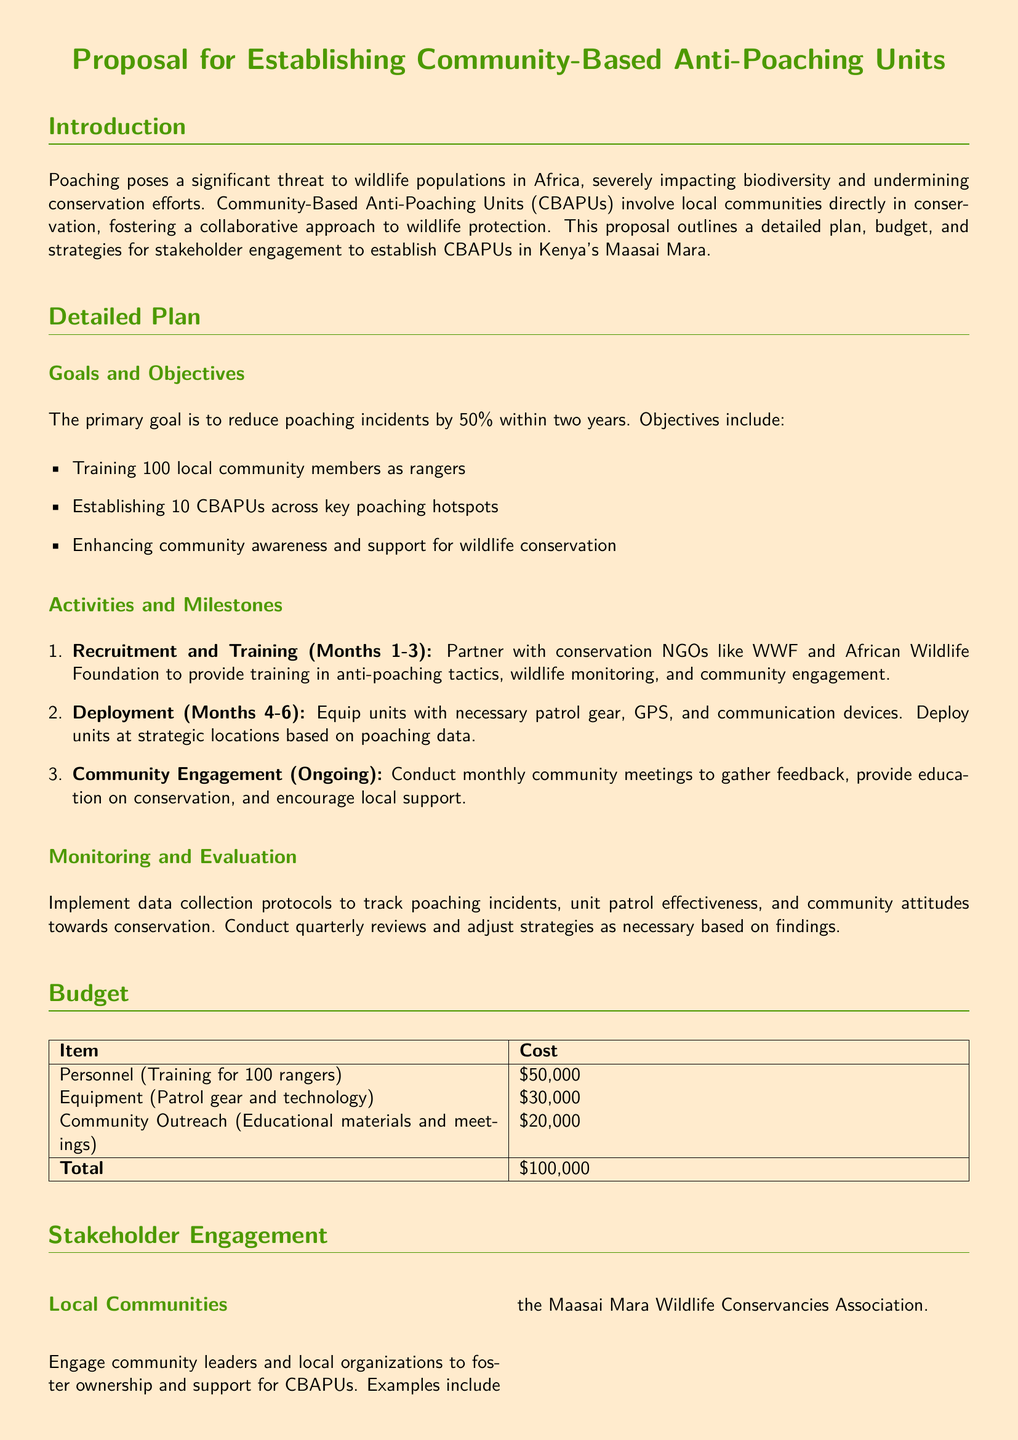What is the primary goal of the proposal? The primary goal, as stated in the proposal, is to reduce poaching incidents by 50% within two years.
Answer: 50% How many local community members will be trained as rangers? The proposal mentions training 100 local community members as rangers.
Answer: 100 What is the total budget for establishing the Community-Based Anti-Poaching Units? The total budget outlined in the proposal sums up all costs, which is $50,000 plus $30,000 plus $20,000.
Answer: $100,000 Which organization is mentioned for collaboration in training? The proposal mentions partnering with conservation NGOs like WWF and African Wildlife Foundation for training.
Answer: WWF and African Wildlife Foundation How many Community-Based Anti-Poaching Units will be established? The proposal states that 10 CBAPUs will be established across key poaching hotspots.
Answer: 10 What type of data will be collected for monitoring and evaluation? The proposal will implement data collection protocols to track poaching incidents and unit patrol effectiveness, among other metrics.
Answer: Poaching incidents and unit patrol effectiveness Which international entity is mentioned for potential funding? The proposal seeks funding from the United Nations Development Programme (UNDP) as a potential funding partner.
Answer: United Nations Development Programme What is one of the main activities planned for community engagement? The proposal includes conducting monthly community meetings as a main activity for engagement.
Answer: Monthly community meetings 